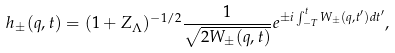<formula> <loc_0><loc_0><loc_500><loc_500>h _ { \pm } ( { q } , t ) = ( 1 + Z _ { \Lambda } ) ^ { - 1 / 2 } \frac { 1 } { \sqrt { 2 W _ { \pm } ( { q } , t ) } } e ^ { \pm i \int _ { - T } ^ { t } W _ { \pm } ( { q } , t ^ { \prime } ) d t ^ { \prime } } ,</formula> 